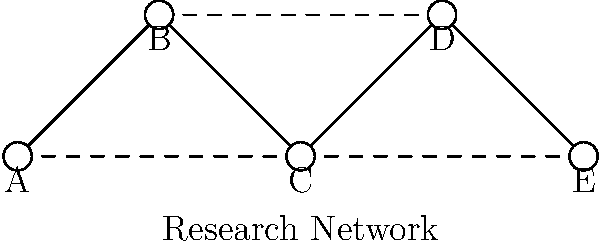In a research network with sensitive data, as shown in the diagram, nodes A, C, and E represent secure servers, while nodes B and D are potential entry points for unauthorized access. If an intruder gains access to node B, what is the minimum number of additional nodes they need to compromise to access all secure servers, assuming they can only move along existing connections? To solve this problem, we need to analyze the network structure and determine the most efficient path for the intruder to access all secure servers. Let's break it down step-by-step:

1. The intruder starts at node B.

2. From node B, they have direct access to nodes A and C:
   - Node A is already a secure server.
   - Node C is also a secure server.

3. To reach node E (the last secure server), the intruder has two options:
   a. Go through node C, which is already compromised.
   b. Go through node D, which would require compromising an additional node.

4. The most efficient path is to use the already compromised node C to reach node E.

5. Therefore, the intruder only needs to compromise node B (which is given in the question) to access all secure servers (A, C, and E).

6. The minimum number of additional nodes to compromise is 0, as node B provides access to all required paths.

This scenario highlights the importance of securing potential entry points (like nodes B and D) and implementing proper access controls and network segmentation to prevent unauthorized access to sensitive research data.
Answer: 0 